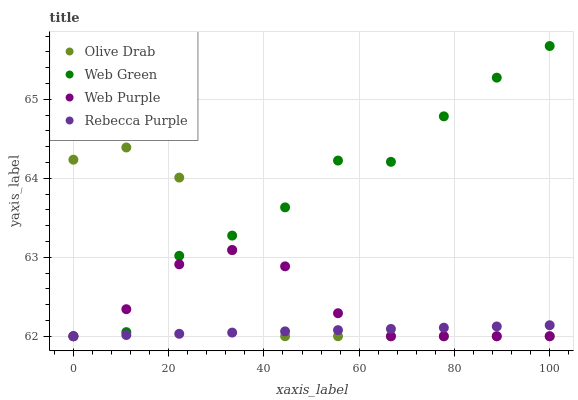Does Rebecca Purple have the minimum area under the curve?
Answer yes or no. Yes. Does Web Green have the maximum area under the curve?
Answer yes or no. Yes. Does Olive Drab have the minimum area under the curve?
Answer yes or no. No. Does Olive Drab have the maximum area under the curve?
Answer yes or no. No. Is Rebecca Purple the smoothest?
Answer yes or no. Yes. Is Web Green the roughest?
Answer yes or no. Yes. Is Olive Drab the smoothest?
Answer yes or no. No. Is Olive Drab the roughest?
Answer yes or no. No. Does Web Purple have the lowest value?
Answer yes or no. Yes. Does Web Green have the highest value?
Answer yes or no. Yes. Does Olive Drab have the highest value?
Answer yes or no. No. Does Olive Drab intersect Rebecca Purple?
Answer yes or no. Yes. Is Olive Drab less than Rebecca Purple?
Answer yes or no. No. Is Olive Drab greater than Rebecca Purple?
Answer yes or no. No. 